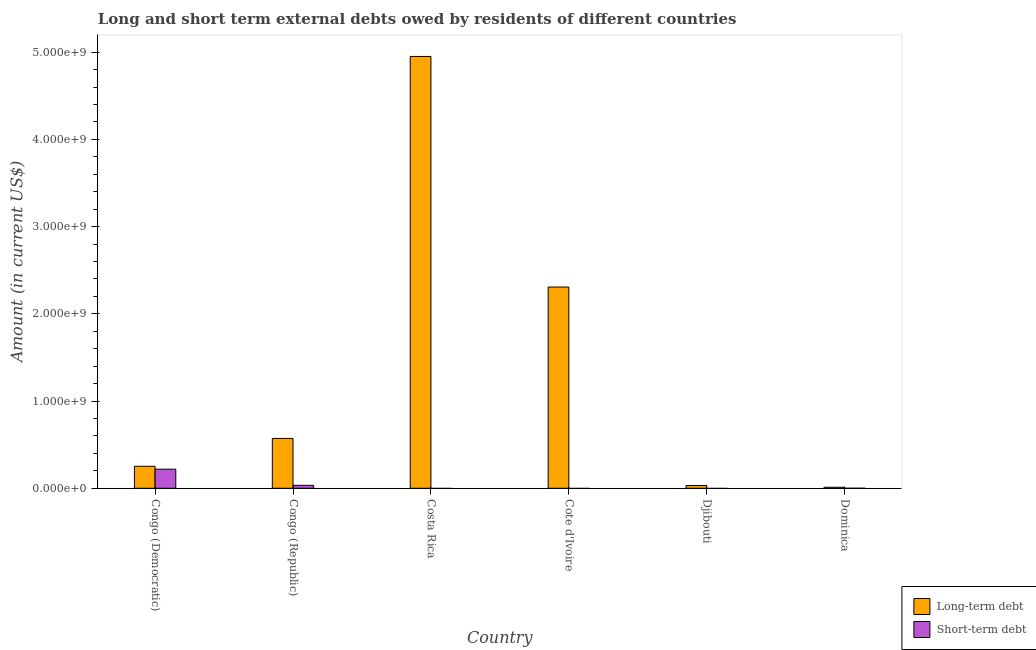How many different coloured bars are there?
Your answer should be compact. 2. How many bars are there on the 2nd tick from the right?
Keep it short and to the point. 1. What is the label of the 6th group of bars from the left?
Make the answer very short. Dominica. In how many cases, is the number of bars for a given country not equal to the number of legend labels?
Your response must be concise. 3. What is the long-term debts owed by residents in Djibouti?
Your answer should be compact. 3.22e+07. Across all countries, what is the maximum long-term debts owed by residents?
Ensure brevity in your answer.  4.95e+09. Across all countries, what is the minimum short-term debts owed by residents?
Give a very brief answer. 0. In which country was the long-term debts owed by residents maximum?
Provide a short and direct response. Costa Rica. What is the total short-term debts owed by residents in the graph?
Ensure brevity in your answer.  2.53e+08. What is the difference between the short-term debts owed by residents in Congo (Democratic) and that in Dominica?
Provide a succinct answer. 2.19e+08. What is the difference between the short-term debts owed by residents in Congo (Republic) and the long-term debts owed by residents in Djibouti?
Your response must be concise. 1.80e+06. What is the average long-term debts owed by residents per country?
Make the answer very short. 1.35e+09. What is the difference between the long-term debts owed by residents and short-term debts owed by residents in Dominica?
Your answer should be very brief. 1.16e+07. What is the ratio of the short-term debts owed by residents in Congo (Democratic) to that in Dominica?
Your response must be concise. 5.48e+04. Is the long-term debts owed by residents in Cote d'Ivoire less than that in Dominica?
Keep it short and to the point. No. What is the difference between the highest and the second highest long-term debts owed by residents?
Your answer should be compact. 2.64e+09. What is the difference between the highest and the lowest long-term debts owed by residents?
Offer a terse response. 4.94e+09. Does the graph contain grids?
Your answer should be very brief. No. Where does the legend appear in the graph?
Provide a succinct answer. Bottom right. How many legend labels are there?
Your answer should be compact. 2. What is the title of the graph?
Give a very brief answer. Long and short term external debts owed by residents of different countries. Does "Travel services" appear as one of the legend labels in the graph?
Give a very brief answer. No. What is the label or title of the X-axis?
Provide a succinct answer. Country. What is the label or title of the Y-axis?
Offer a very short reply. Amount (in current US$). What is the Amount (in current US$) of Long-term debt in Congo (Democratic)?
Your response must be concise. 2.52e+08. What is the Amount (in current US$) in Short-term debt in Congo (Democratic)?
Offer a terse response. 2.19e+08. What is the Amount (in current US$) of Long-term debt in Congo (Republic)?
Your answer should be compact. 5.72e+08. What is the Amount (in current US$) of Short-term debt in Congo (Republic)?
Your answer should be compact. 3.40e+07. What is the Amount (in current US$) of Long-term debt in Costa Rica?
Ensure brevity in your answer.  4.95e+09. What is the Amount (in current US$) of Short-term debt in Costa Rica?
Make the answer very short. 0. What is the Amount (in current US$) of Long-term debt in Cote d'Ivoire?
Keep it short and to the point. 2.31e+09. What is the Amount (in current US$) of Short-term debt in Cote d'Ivoire?
Keep it short and to the point. 0. What is the Amount (in current US$) in Long-term debt in Djibouti?
Provide a short and direct response. 3.22e+07. What is the Amount (in current US$) of Short-term debt in Djibouti?
Offer a very short reply. 0. What is the Amount (in current US$) of Long-term debt in Dominica?
Ensure brevity in your answer.  1.16e+07. What is the Amount (in current US$) in Short-term debt in Dominica?
Keep it short and to the point. 4000. Across all countries, what is the maximum Amount (in current US$) of Long-term debt?
Provide a short and direct response. 4.95e+09. Across all countries, what is the maximum Amount (in current US$) in Short-term debt?
Provide a succinct answer. 2.19e+08. Across all countries, what is the minimum Amount (in current US$) in Long-term debt?
Your answer should be compact. 1.16e+07. Across all countries, what is the minimum Amount (in current US$) in Short-term debt?
Offer a terse response. 0. What is the total Amount (in current US$) of Long-term debt in the graph?
Give a very brief answer. 8.12e+09. What is the total Amount (in current US$) in Short-term debt in the graph?
Make the answer very short. 2.53e+08. What is the difference between the Amount (in current US$) in Long-term debt in Congo (Democratic) and that in Congo (Republic)?
Your answer should be very brief. -3.20e+08. What is the difference between the Amount (in current US$) in Short-term debt in Congo (Democratic) and that in Congo (Republic)?
Keep it short and to the point. 1.85e+08. What is the difference between the Amount (in current US$) of Long-term debt in Congo (Democratic) and that in Costa Rica?
Make the answer very short. -4.70e+09. What is the difference between the Amount (in current US$) in Long-term debt in Congo (Democratic) and that in Cote d'Ivoire?
Give a very brief answer. -2.05e+09. What is the difference between the Amount (in current US$) of Long-term debt in Congo (Democratic) and that in Djibouti?
Your response must be concise. 2.20e+08. What is the difference between the Amount (in current US$) in Long-term debt in Congo (Democratic) and that in Dominica?
Provide a succinct answer. 2.41e+08. What is the difference between the Amount (in current US$) of Short-term debt in Congo (Democratic) and that in Dominica?
Keep it short and to the point. 2.19e+08. What is the difference between the Amount (in current US$) in Long-term debt in Congo (Republic) and that in Costa Rica?
Keep it short and to the point. -4.38e+09. What is the difference between the Amount (in current US$) in Long-term debt in Congo (Republic) and that in Cote d'Ivoire?
Keep it short and to the point. -1.74e+09. What is the difference between the Amount (in current US$) of Long-term debt in Congo (Republic) and that in Djibouti?
Your answer should be compact. 5.39e+08. What is the difference between the Amount (in current US$) of Long-term debt in Congo (Republic) and that in Dominica?
Make the answer very short. 5.60e+08. What is the difference between the Amount (in current US$) in Short-term debt in Congo (Republic) and that in Dominica?
Your answer should be very brief. 3.40e+07. What is the difference between the Amount (in current US$) in Long-term debt in Costa Rica and that in Cote d'Ivoire?
Keep it short and to the point. 2.64e+09. What is the difference between the Amount (in current US$) of Long-term debt in Costa Rica and that in Djibouti?
Your answer should be compact. 4.92e+09. What is the difference between the Amount (in current US$) in Long-term debt in Costa Rica and that in Dominica?
Provide a succinct answer. 4.94e+09. What is the difference between the Amount (in current US$) in Long-term debt in Cote d'Ivoire and that in Djibouti?
Your answer should be very brief. 2.27e+09. What is the difference between the Amount (in current US$) of Long-term debt in Cote d'Ivoire and that in Dominica?
Offer a terse response. 2.30e+09. What is the difference between the Amount (in current US$) of Long-term debt in Djibouti and that in Dominica?
Provide a short and direct response. 2.06e+07. What is the difference between the Amount (in current US$) in Long-term debt in Congo (Democratic) and the Amount (in current US$) in Short-term debt in Congo (Republic)?
Provide a succinct answer. 2.18e+08. What is the difference between the Amount (in current US$) of Long-term debt in Congo (Democratic) and the Amount (in current US$) of Short-term debt in Dominica?
Ensure brevity in your answer.  2.52e+08. What is the difference between the Amount (in current US$) in Long-term debt in Congo (Republic) and the Amount (in current US$) in Short-term debt in Dominica?
Your response must be concise. 5.72e+08. What is the difference between the Amount (in current US$) in Long-term debt in Costa Rica and the Amount (in current US$) in Short-term debt in Dominica?
Give a very brief answer. 4.95e+09. What is the difference between the Amount (in current US$) of Long-term debt in Cote d'Ivoire and the Amount (in current US$) of Short-term debt in Dominica?
Your answer should be compact. 2.31e+09. What is the difference between the Amount (in current US$) in Long-term debt in Djibouti and the Amount (in current US$) in Short-term debt in Dominica?
Ensure brevity in your answer.  3.22e+07. What is the average Amount (in current US$) in Long-term debt per country?
Make the answer very short. 1.35e+09. What is the average Amount (in current US$) of Short-term debt per country?
Your answer should be very brief. 4.22e+07. What is the difference between the Amount (in current US$) of Long-term debt and Amount (in current US$) of Short-term debt in Congo (Democratic)?
Ensure brevity in your answer.  3.31e+07. What is the difference between the Amount (in current US$) in Long-term debt and Amount (in current US$) in Short-term debt in Congo (Republic)?
Your answer should be very brief. 5.38e+08. What is the difference between the Amount (in current US$) of Long-term debt and Amount (in current US$) of Short-term debt in Dominica?
Your answer should be compact. 1.16e+07. What is the ratio of the Amount (in current US$) of Long-term debt in Congo (Democratic) to that in Congo (Republic)?
Your response must be concise. 0.44. What is the ratio of the Amount (in current US$) in Short-term debt in Congo (Democratic) to that in Congo (Republic)?
Ensure brevity in your answer.  6.44. What is the ratio of the Amount (in current US$) of Long-term debt in Congo (Democratic) to that in Costa Rica?
Your answer should be compact. 0.05. What is the ratio of the Amount (in current US$) of Long-term debt in Congo (Democratic) to that in Cote d'Ivoire?
Make the answer very short. 0.11. What is the ratio of the Amount (in current US$) of Long-term debt in Congo (Democratic) to that in Djibouti?
Your answer should be very brief. 7.83. What is the ratio of the Amount (in current US$) of Long-term debt in Congo (Democratic) to that in Dominica?
Offer a very short reply. 21.81. What is the ratio of the Amount (in current US$) in Short-term debt in Congo (Democratic) to that in Dominica?
Provide a short and direct response. 5.48e+04. What is the ratio of the Amount (in current US$) of Long-term debt in Congo (Republic) to that in Costa Rica?
Give a very brief answer. 0.12. What is the ratio of the Amount (in current US$) of Long-term debt in Congo (Republic) to that in Cote d'Ivoire?
Provide a succinct answer. 0.25. What is the ratio of the Amount (in current US$) in Long-term debt in Congo (Republic) to that in Djibouti?
Your answer should be very brief. 17.75. What is the ratio of the Amount (in current US$) in Long-term debt in Congo (Republic) to that in Dominica?
Your answer should be compact. 49.46. What is the ratio of the Amount (in current US$) of Short-term debt in Congo (Republic) to that in Dominica?
Your answer should be very brief. 8500. What is the ratio of the Amount (in current US$) in Long-term debt in Costa Rica to that in Cote d'Ivoire?
Give a very brief answer. 2.15. What is the ratio of the Amount (in current US$) in Long-term debt in Costa Rica to that in Djibouti?
Your answer should be very brief. 153.72. What is the ratio of the Amount (in current US$) of Long-term debt in Costa Rica to that in Dominica?
Provide a short and direct response. 428.28. What is the ratio of the Amount (in current US$) of Long-term debt in Cote d'Ivoire to that in Djibouti?
Make the answer very short. 71.64. What is the ratio of the Amount (in current US$) in Long-term debt in Cote d'Ivoire to that in Dominica?
Provide a short and direct response. 199.6. What is the ratio of the Amount (in current US$) in Long-term debt in Djibouti to that in Dominica?
Your answer should be very brief. 2.79. What is the difference between the highest and the second highest Amount (in current US$) of Long-term debt?
Make the answer very short. 2.64e+09. What is the difference between the highest and the second highest Amount (in current US$) in Short-term debt?
Keep it short and to the point. 1.85e+08. What is the difference between the highest and the lowest Amount (in current US$) of Long-term debt?
Your answer should be very brief. 4.94e+09. What is the difference between the highest and the lowest Amount (in current US$) in Short-term debt?
Give a very brief answer. 2.19e+08. 